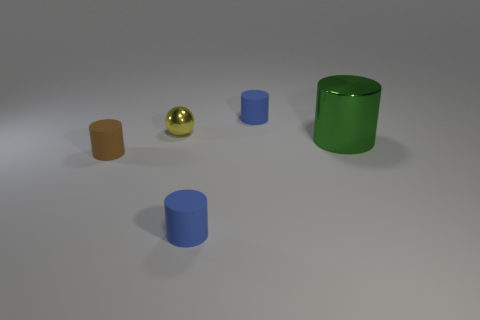Is there any other thing that has the same shape as the tiny yellow metal object?
Ensure brevity in your answer.  No. There is a tiny object left of the yellow ball; does it have the same shape as the small yellow metal thing that is to the left of the green object?
Keep it short and to the point. No. What is the shape of the brown thing that is the same size as the yellow metal ball?
Keep it short and to the point. Cylinder. There is a small brown object; are there any blue rubber cylinders behind it?
Give a very brief answer. Yes. There is a brown cylinder; does it have the same size as the blue thing behind the tiny yellow sphere?
Keep it short and to the point. Yes. What color is the matte object left of the metallic ball that is on the right side of the small brown rubber thing?
Your answer should be very brief. Brown. Does the brown matte object have the same size as the yellow metal ball?
Offer a very short reply. Yes. There is a cylinder that is right of the tiny brown rubber cylinder and in front of the green cylinder; what is its color?
Provide a short and direct response. Blue. What is the size of the brown rubber object?
Provide a succinct answer. Small. Are there more rubber cylinders to the left of the small shiny thing than small yellow spheres that are in front of the big metallic cylinder?
Give a very brief answer. Yes. 